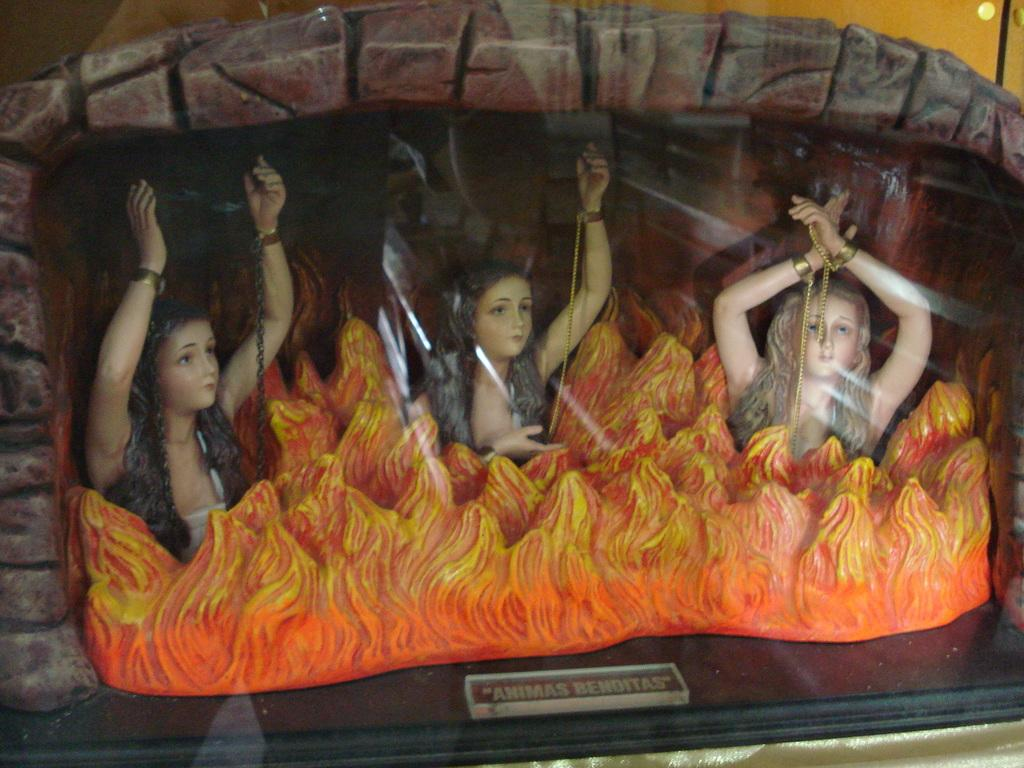What is the main feature of the image? There is a fireplace in the image. What is the fireplace made of or created with? The fireplace is created with something, but the specific material is not mentioned in the facts. How many women dolls are in the fireplace? There are three women dolls in the fireplace. What is happening inside the fireplace? There is fire present in the fireplace. What type of grass is growing near the fireplace in the image? There is no grass visible in the image; it only features a fireplace with three women dolls and fire inside. 